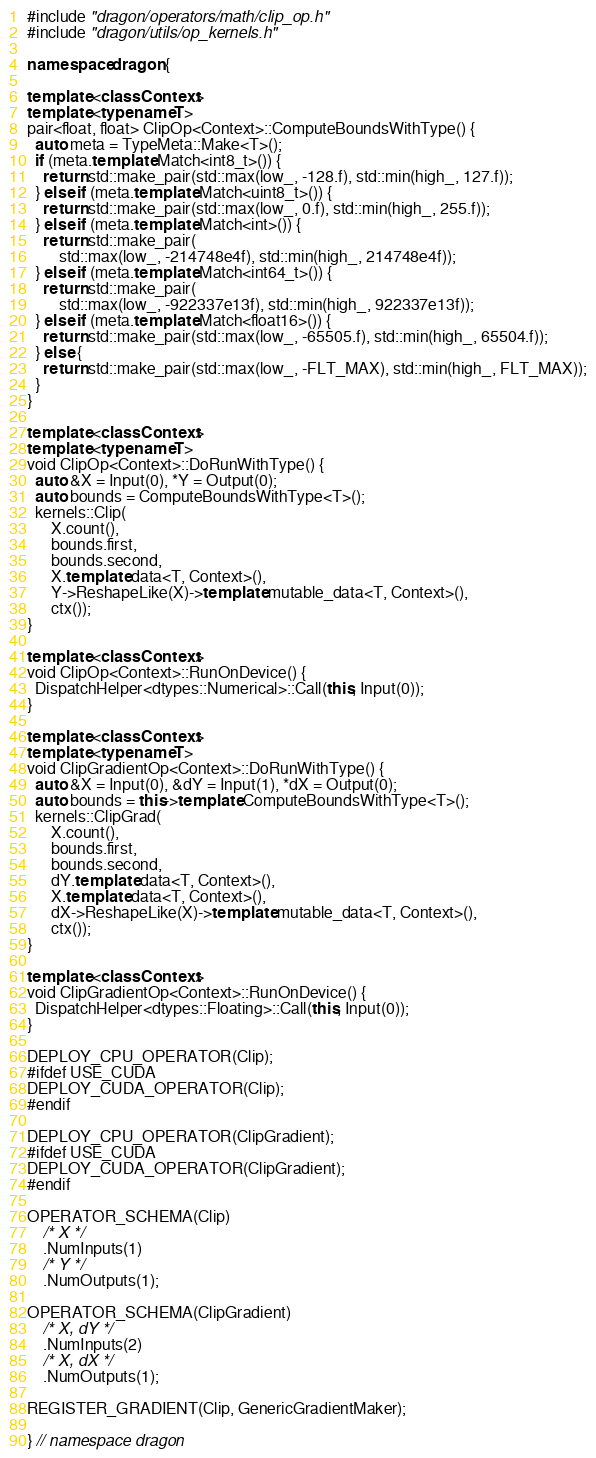<code> <loc_0><loc_0><loc_500><loc_500><_C++_>#include "dragon/operators/math/clip_op.h"
#include "dragon/utils/op_kernels.h"

namespace dragon {

template <class Context>
template <typename T>
pair<float, float> ClipOp<Context>::ComputeBoundsWithType() {
  auto meta = TypeMeta::Make<T>();
  if (meta.template Match<int8_t>()) {
    return std::make_pair(std::max(low_, -128.f), std::min(high_, 127.f));
  } else if (meta.template Match<uint8_t>()) {
    return std::make_pair(std::max(low_, 0.f), std::min(high_, 255.f));
  } else if (meta.template Match<int>()) {
    return std::make_pair(
        std::max(low_, -214748e4f), std::min(high_, 214748e4f));
  } else if (meta.template Match<int64_t>()) {
    return std::make_pair(
        std::max(low_, -922337e13f), std::min(high_, 922337e13f));
  } else if (meta.template Match<float16>()) {
    return std::make_pair(std::max(low_, -65505.f), std::min(high_, 65504.f));
  } else {
    return std::make_pair(std::max(low_, -FLT_MAX), std::min(high_, FLT_MAX));
  }
}

template <class Context>
template <typename T>
void ClipOp<Context>::DoRunWithType() {
  auto &X = Input(0), *Y = Output(0);
  auto bounds = ComputeBoundsWithType<T>();
  kernels::Clip(
      X.count(),
      bounds.first,
      bounds.second,
      X.template data<T, Context>(),
      Y->ReshapeLike(X)->template mutable_data<T, Context>(),
      ctx());
}

template <class Context>
void ClipOp<Context>::RunOnDevice() {
  DispatchHelper<dtypes::Numerical>::Call(this, Input(0));
}

template <class Context>
template <typename T>
void ClipGradientOp<Context>::DoRunWithType() {
  auto &X = Input(0), &dY = Input(1), *dX = Output(0);
  auto bounds = this->template ComputeBoundsWithType<T>();
  kernels::ClipGrad(
      X.count(),
      bounds.first,
      bounds.second,
      dY.template data<T, Context>(),
      X.template data<T, Context>(),
      dX->ReshapeLike(X)->template mutable_data<T, Context>(),
      ctx());
}

template <class Context>
void ClipGradientOp<Context>::RunOnDevice() {
  DispatchHelper<dtypes::Floating>::Call(this, Input(0));
}

DEPLOY_CPU_OPERATOR(Clip);
#ifdef USE_CUDA
DEPLOY_CUDA_OPERATOR(Clip);
#endif

DEPLOY_CPU_OPERATOR(ClipGradient);
#ifdef USE_CUDA
DEPLOY_CUDA_OPERATOR(ClipGradient);
#endif

OPERATOR_SCHEMA(Clip)
    /* X */
    .NumInputs(1)
    /* Y */
    .NumOutputs(1);

OPERATOR_SCHEMA(ClipGradient)
    /* X, dY */
    .NumInputs(2)
    /* X, dX */
    .NumOutputs(1);

REGISTER_GRADIENT(Clip, GenericGradientMaker);

} // namespace dragon
</code> 